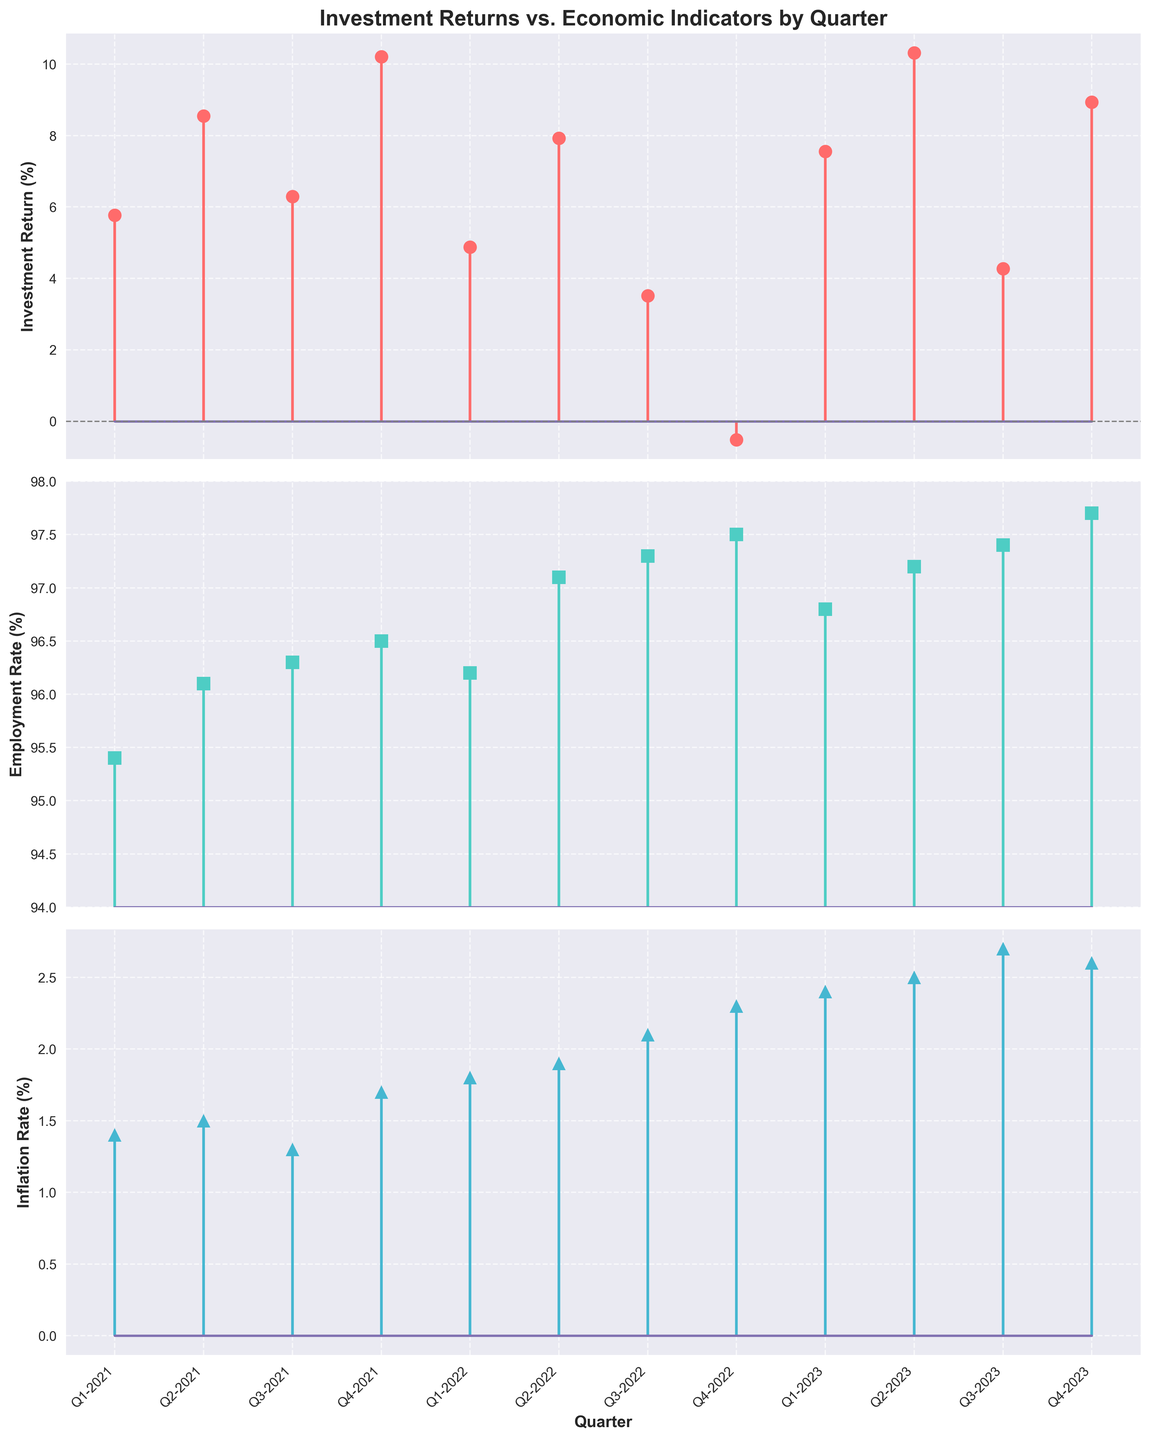What is the title of the figure? Look at the top of the first subplot where the figure title is displayed. The title gives an overview of what the figure is about.
Answer: Investment Returns vs. Economic Indicators by Quarter What is the employment rate in Q4-2022? Locate Q4-2022 on the x-axis of the second subplot that represents the employment rate. Follow the stem line to find the corresponding y-axis value.
Answer: 97.5% Which quarter shows the highest investment return? Examine the first subplot (Investment Return). Compare the heights of the stems and identify the tallest one corresponding to a particular quarter.
Answer: Q2-2023 When does inflation rate cross the 2% mark? Check the third subplot (Inflation Rate). Find the quarter where the stem surpasses the 2% value on the y-axis.
Answer: Q3-2022 Compare the investment returns in Q4-2022 and Q1-2023. Which one is higher? In the first subplot (Investment Return), locate Q4-2022 and Q1-2023 on the x-axis, then compare the heights of the corresponding stems to see which is higher.
Answer: Q1-2023 What is the difference in the employment rate between Q2-2022 and Q4-2023? Look at the employment rate subplot and find the values for Q2-2022 and Q4-2023. Subtract the Q2-2022 value from the Q4-2023 value.
Answer: 0.6% (97.7% - 97.1%) What trend can you observe in the inflation rate from Q1-2021 to Q4-2023? Follow the stems in the third subplot (Inflation Rate) from Q1-2021 to Q4-2023 and describe the pattern of increase or decrease.
Answer: Increasing trend How many quarters show negative investment returns? Identify the stems in the first subplot (Investment Return) that drop below the x-axis indicating negative returns. Count these quarters.
Answer: 1 quarter What was the inflation rate in Q1-2021 and how does it compare to Q4-2023? Find the inflation rates in the third subplot for Q1-2021 and Q4-2023, then compare the two values to see the difference.
Answer: 1.4% in Q1-2021, less than Q4-2023 which is 2.6% Is the employment rate generally increasing or decreasing over the quarters? Observing the second subplot (Employment Rate), track the direction of the stems over the quarters to identify the general trend.
Answer: Increasing trend 